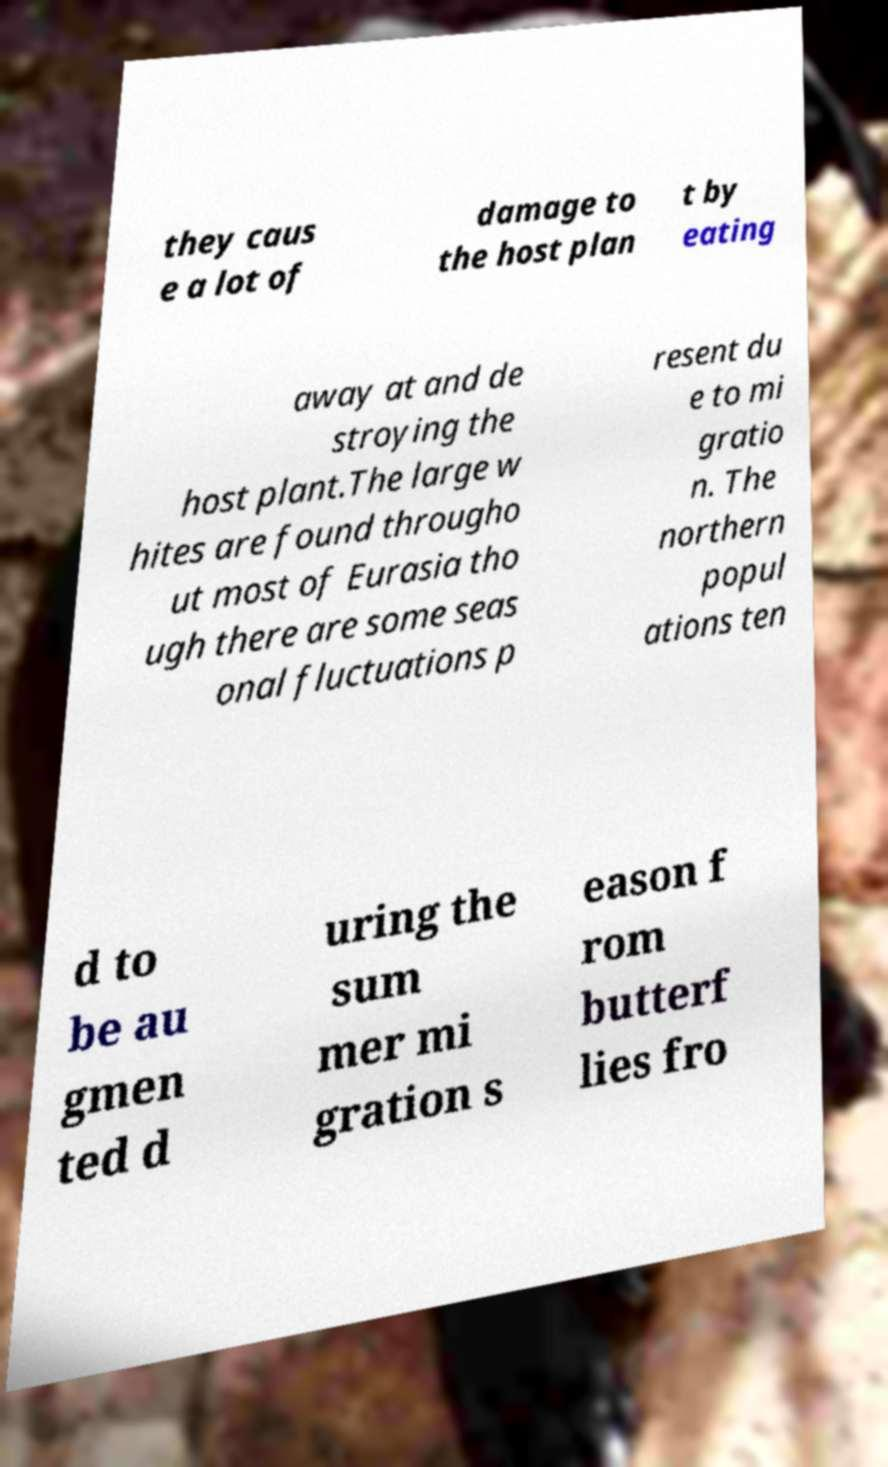Can you read and provide the text displayed in the image?This photo seems to have some interesting text. Can you extract and type it out for me? they caus e a lot of damage to the host plan t by eating away at and de stroying the host plant.The large w hites are found througho ut most of Eurasia tho ugh there are some seas onal fluctuations p resent du e to mi gratio n. The northern popul ations ten d to be au gmen ted d uring the sum mer mi gration s eason f rom butterf lies fro 